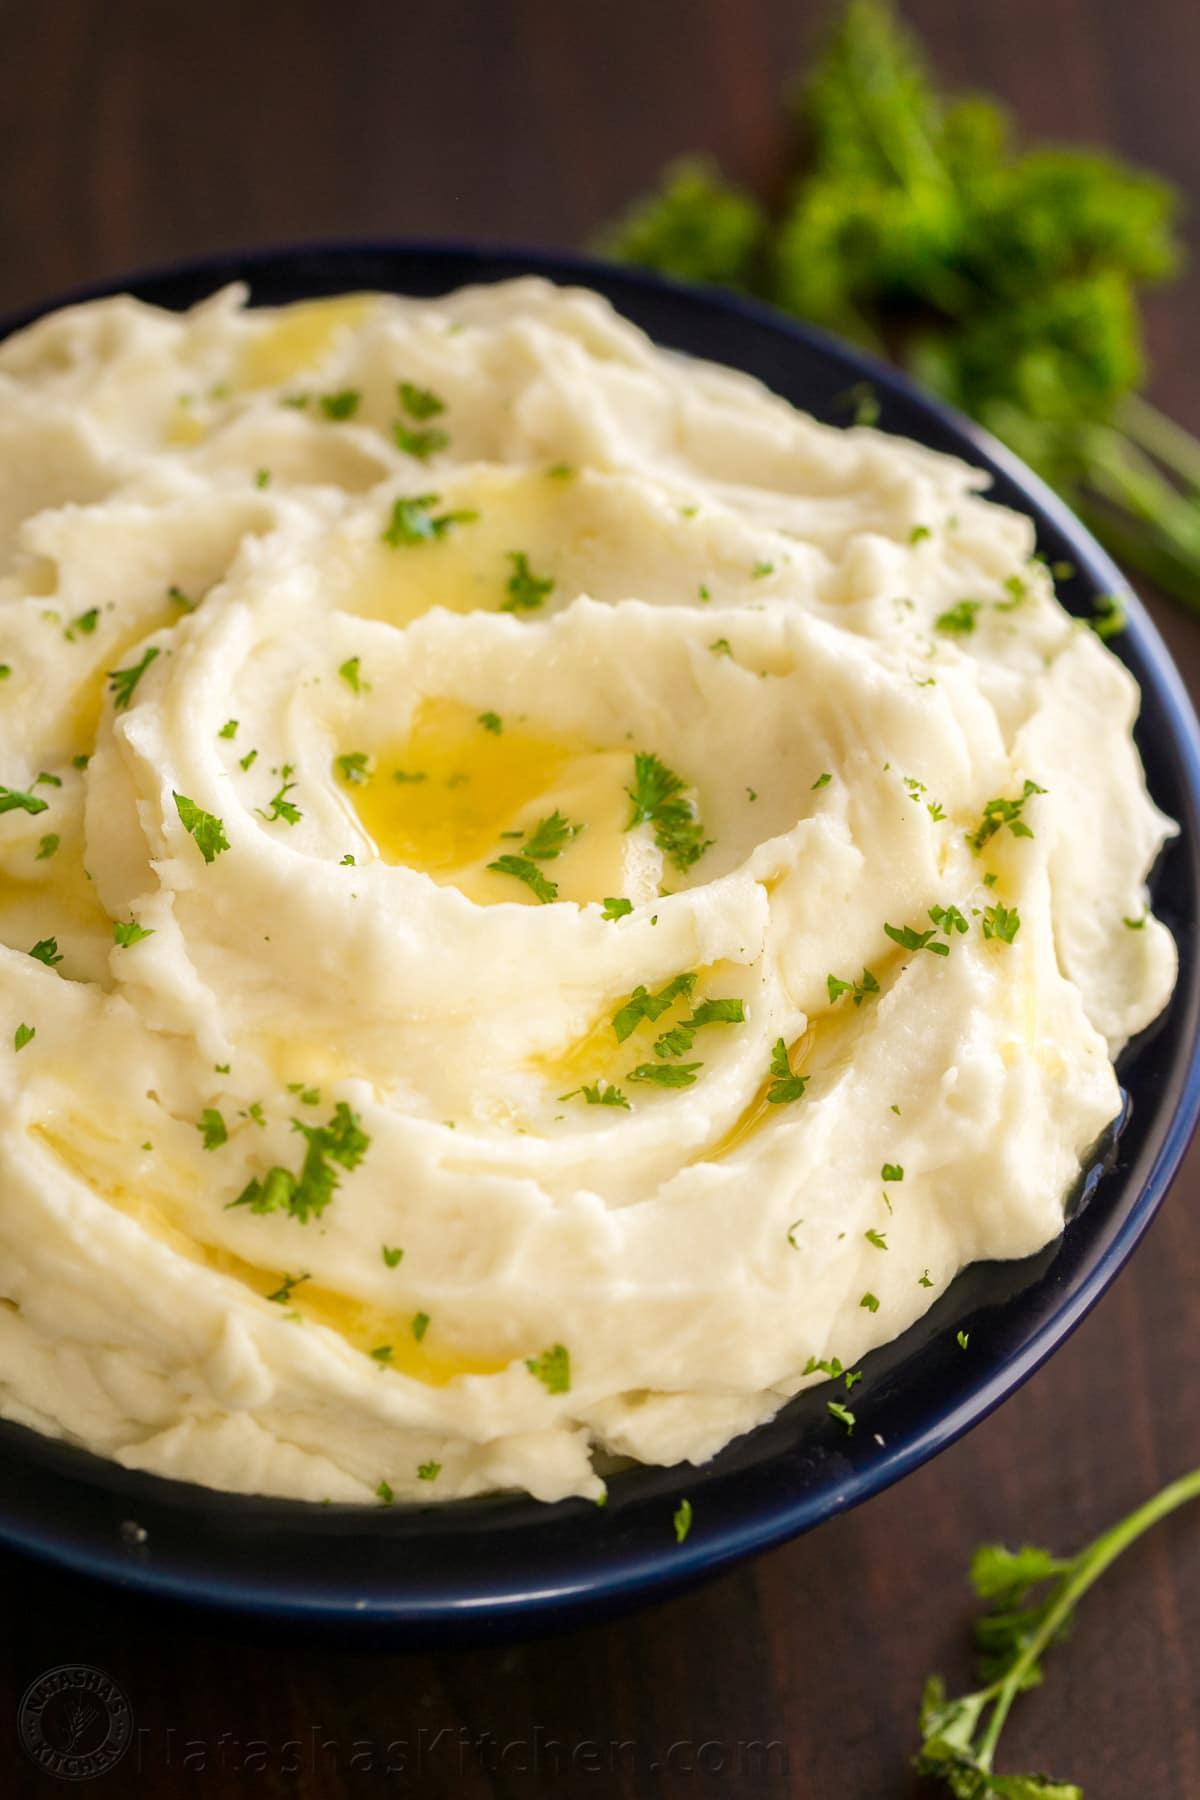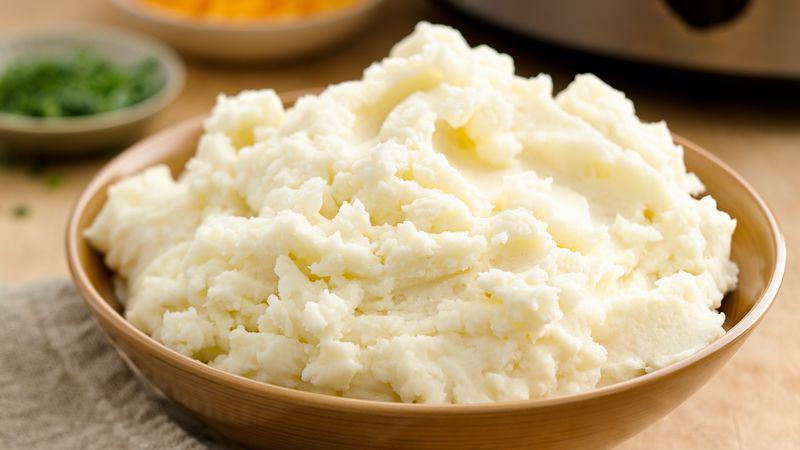The first image is the image on the left, the second image is the image on the right. For the images shown, is this caption "An image shows a red container with a fork next to it." true? Answer yes or no. No. The first image is the image on the left, the second image is the image on the right. Analyze the images presented: Is the assertion "In one image, mashed potatoes are served in a red bowl with a pat of butter and chopped chives." valid? Answer yes or no. No. 